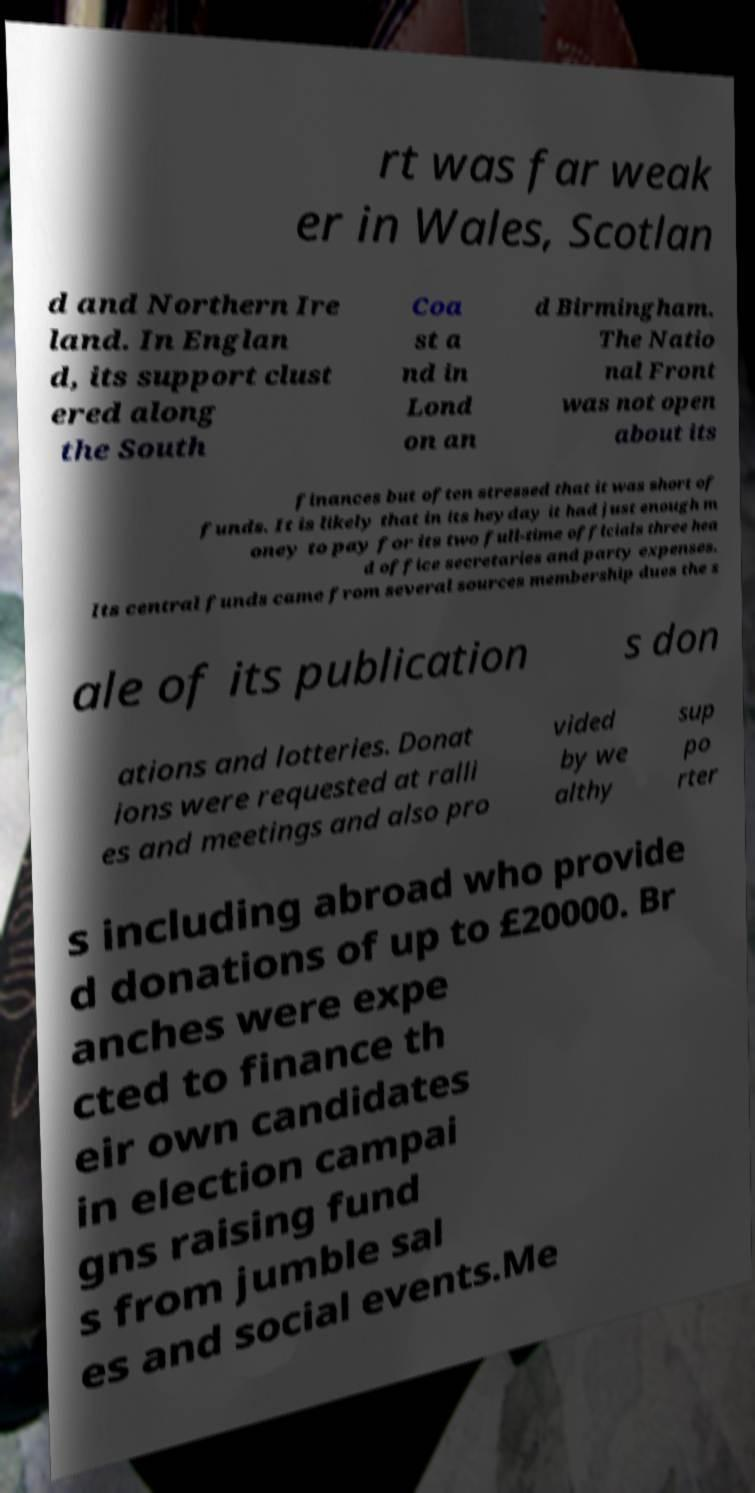Can you read and provide the text displayed in the image?This photo seems to have some interesting text. Can you extract and type it out for me? rt was far weak er in Wales, Scotlan d and Northern Ire land. In Englan d, its support clust ered along the South Coa st a nd in Lond on an d Birmingham. The Natio nal Front was not open about its finances but often stressed that it was short of funds. It is likely that in its heyday it had just enough m oney to pay for its two full-time officials three hea d office secretaries and party expenses. Its central funds came from several sources membership dues the s ale of its publication s don ations and lotteries. Donat ions were requested at ralli es and meetings and also pro vided by we althy sup po rter s including abroad who provide d donations of up to £20000. Br anches were expe cted to finance th eir own candidates in election campai gns raising fund s from jumble sal es and social events.Me 